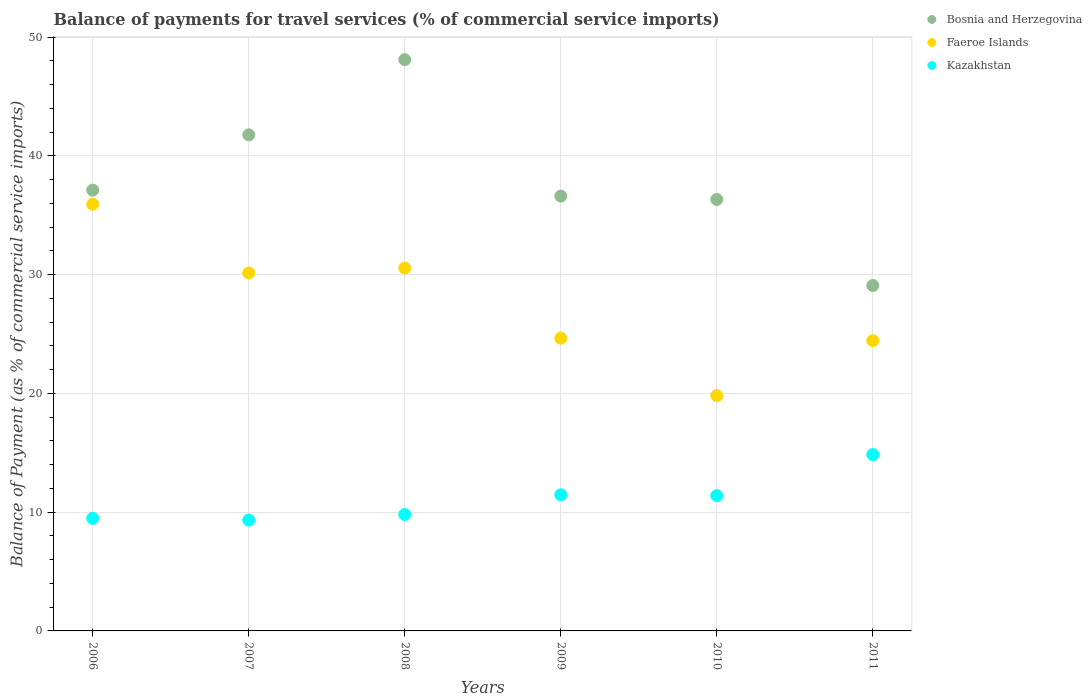Is the number of dotlines equal to the number of legend labels?
Keep it short and to the point. Yes. What is the balance of payments for travel services in Bosnia and Herzegovina in 2008?
Keep it short and to the point. 48.11. Across all years, what is the maximum balance of payments for travel services in Kazakhstan?
Your response must be concise. 14.85. Across all years, what is the minimum balance of payments for travel services in Kazakhstan?
Make the answer very short. 9.33. In which year was the balance of payments for travel services in Faeroe Islands maximum?
Offer a terse response. 2006. What is the total balance of payments for travel services in Faeroe Islands in the graph?
Provide a short and direct response. 165.53. What is the difference between the balance of payments for travel services in Faeroe Islands in 2007 and that in 2010?
Provide a short and direct response. 10.33. What is the difference between the balance of payments for travel services in Bosnia and Herzegovina in 2006 and the balance of payments for travel services in Kazakhstan in 2007?
Offer a very short reply. 27.79. What is the average balance of payments for travel services in Bosnia and Herzegovina per year?
Keep it short and to the point. 38.17. In the year 2006, what is the difference between the balance of payments for travel services in Bosnia and Herzegovina and balance of payments for travel services in Faeroe Islands?
Ensure brevity in your answer.  1.19. What is the ratio of the balance of payments for travel services in Faeroe Islands in 2008 to that in 2011?
Offer a very short reply. 1.25. What is the difference between the highest and the second highest balance of payments for travel services in Bosnia and Herzegovina?
Provide a short and direct response. 6.34. What is the difference between the highest and the lowest balance of payments for travel services in Kazakhstan?
Offer a terse response. 5.52. In how many years, is the balance of payments for travel services in Faeroe Islands greater than the average balance of payments for travel services in Faeroe Islands taken over all years?
Ensure brevity in your answer.  3. Is it the case that in every year, the sum of the balance of payments for travel services in Bosnia and Herzegovina and balance of payments for travel services in Faeroe Islands  is greater than the balance of payments for travel services in Kazakhstan?
Ensure brevity in your answer.  Yes. Is the balance of payments for travel services in Kazakhstan strictly greater than the balance of payments for travel services in Faeroe Islands over the years?
Make the answer very short. No. Are the values on the major ticks of Y-axis written in scientific E-notation?
Offer a terse response. No. Does the graph contain grids?
Offer a terse response. Yes. What is the title of the graph?
Your answer should be very brief. Balance of payments for travel services (% of commercial service imports). What is the label or title of the X-axis?
Ensure brevity in your answer.  Years. What is the label or title of the Y-axis?
Provide a succinct answer. Balance of Payment (as % of commercial service imports). What is the Balance of Payment (as % of commercial service imports) of Bosnia and Herzegovina in 2006?
Your response must be concise. 37.12. What is the Balance of Payment (as % of commercial service imports) in Faeroe Islands in 2006?
Provide a short and direct response. 35.93. What is the Balance of Payment (as % of commercial service imports) in Kazakhstan in 2006?
Your answer should be compact. 9.48. What is the Balance of Payment (as % of commercial service imports) of Bosnia and Herzegovina in 2007?
Provide a short and direct response. 41.77. What is the Balance of Payment (as % of commercial service imports) of Faeroe Islands in 2007?
Make the answer very short. 30.14. What is the Balance of Payment (as % of commercial service imports) in Kazakhstan in 2007?
Give a very brief answer. 9.33. What is the Balance of Payment (as % of commercial service imports) of Bosnia and Herzegovina in 2008?
Make the answer very short. 48.11. What is the Balance of Payment (as % of commercial service imports) of Faeroe Islands in 2008?
Provide a succinct answer. 30.55. What is the Balance of Payment (as % of commercial service imports) of Kazakhstan in 2008?
Offer a very short reply. 9.8. What is the Balance of Payment (as % of commercial service imports) of Bosnia and Herzegovina in 2009?
Give a very brief answer. 36.61. What is the Balance of Payment (as % of commercial service imports) of Faeroe Islands in 2009?
Your answer should be compact. 24.65. What is the Balance of Payment (as % of commercial service imports) in Kazakhstan in 2009?
Provide a short and direct response. 11.46. What is the Balance of Payment (as % of commercial service imports) in Bosnia and Herzegovina in 2010?
Offer a terse response. 36.33. What is the Balance of Payment (as % of commercial service imports) of Faeroe Islands in 2010?
Offer a very short reply. 19.81. What is the Balance of Payment (as % of commercial service imports) in Kazakhstan in 2010?
Keep it short and to the point. 11.39. What is the Balance of Payment (as % of commercial service imports) of Bosnia and Herzegovina in 2011?
Keep it short and to the point. 29.08. What is the Balance of Payment (as % of commercial service imports) in Faeroe Islands in 2011?
Your answer should be very brief. 24.44. What is the Balance of Payment (as % of commercial service imports) in Kazakhstan in 2011?
Give a very brief answer. 14.85. Across all years, what is the maximum Balance of Payment (as % of commercial service imports) in Bosnia and Herzegovina?
Give a very brief answer. 48.11. Across all years, what is the maximum Balance of Payment (as % of commercial service imports) in Faeroe Islands?
Your response must be concise. 35.93. Across all years, what is the maximum Balance of Payment (as % of commercial service imports) of Kazakhstan?
Keep it short and to the point. 14.85. Across all years, what is the minimum Balance of Payment (as % of commercial service imports) of Bosnia and Herzegovina?
Offer a terse response. 29.08. Across all years, what is the minimum Balance of Payment (as % of commercial service imports) of Faeroe Islands?
Keep it short and to the point. 19.81. Across all years, what is the minimum Balance of Payment (as % of commercial service imports) of Kazakhstan?
Give a very brief answer. 9.33. What is the total Balance of Payment (as % of commercial service imports) of Bosnia and Herzegovina in the graph?
Offer a very short reply. 229.02. What is the total Balance of Payment (as % of commercial service imports) in Faeroe Islands in the graph?
Make the answer very short. 165.53. What is the total Balance of Payment (as % of commercial service imports) of Kazakhstan in the graph?
Offer a very short reply. 66.31. What is the difference between the Balance of Payment (as % of commercial service imports) in Bosnia and Herzegovina in 2006 and that in 2007?
Give a very brief answer. -4.66. What is the difference between the Balance of Payment (as % of commercial service imports) in Faeroe Islands in 2006 and that in 2007?
Give a very brief answer. 5.79. What is the difference between the Balance of Payment (as % of commercial service imports) in Kazakhstan in 2006 and that in 2007?
Offer a very short reply. 0.15. What is the difference between the Balance of Payment (as % of commercial service imports) in Bosnia and Herzegovina in 2006 and that in 2008?
Your answer should be compact. -10.99. What is the difference between the Balance of Payment (as % of commercial service imports) in Faeroe Islands in 2006 and that in 2008?
Keep it short and to the point. 5.37. What is the difference between the Balance of Payment (as % of commercial service imports) of Kazakhstan in 2006 and that in 2008?
Offer a terse response. -0.32. What is the difference between the Balance of Payment (as % of commercial service imports) of Bosnia and Herzegovina in 2006 and that in 2009?
Keep it short and to the point. 0.5. What is the difference between the Balance of Payment (as % of commercial service imports) in Faeroe Islands in 2006 and that in 2009?
Provide a succinct answer. 11.27. What is the difference between the Balance of Payment (as % of commercial service imports) of Kazakhstan in 2006 and that in 2009?
Provide a succinct answer. -1.98. What is the difference between the Balance of Payment (as % of commercial service imports) in Bosnia and Herzegovina in 2006 and that in 2010?
Your answer should be very brief. 0.79. What is the difference between the Balance of Payment (as % of commercial service imports) of Faeroe Islands in 2006 and that in 2010?
Give a very brief answer. 16.11. What is the difference between the Balance of Payment (as % of commercial service imports) in Kazakhstan in 2006 and that in 2010?
Your answer should be very brief. -1.91. What is the difference between the Balance of Payment (as % of commercial service imports) in Bosnia and Herzegovina in 2006 and that in 2011?
Offer a terse response. 8.03. What is the difference between the Balance of Payment (as % of commercial service imports) of Faeroe Islands in 2006 and that in 2011?
Provide a short and direct response. 11.49. What is the difference between the Balance of Payment (as % of commercial service imports) in Kazakhstan in 2006 and that in 2011?
Offer a very short reply. -5.37. What is the difference between the Balance of Payment (as % of commercial service imports) in Bosnia and Herzegovina in 2007 and that in 2008?
Keep it short and to the point. -6.34. What is the difference between the Balance of Payment (as % of commercial service imports) of Faeroe Islands in 2007 and that in 2008?
Make the answer very short. -0.41. What is the difference between the Balance of Payment (as % of commercial service imports) of Kazakhstan in 2007 and that in 2008?
Provide a short and direct response. -0.47. What is the difference between the Balance of Payment (as % of commercial service imports) in Bosnia and Herzegovina in 2007 and that in 2009?
Ensure brevity in your answer.  5.16. What is the difference between the Balance of Payment (as % of commercial service imports) of Faeroe Islands in 2007 and that in 2009?
Provide a succinct answer. 5.49. What is the difference between the Balance of Payment (as % of commercial service imports) of Kazakhstan in 2007 and that in 2009?
Your answer should be very brief. -2.13. What is the difference between the Balance of Payment (as % of commercial service imports) in Bosnia and Herzegovina in 2007 and that in 2010?
Provide a succinct answer. 5.44. What is the difference between the Balance of Payment (as % of commercial service imports) of Faeroe Islands in 2007 and that in 2010?
Your response must be concise. 10.33. What is the difference between the Balance of Payment (as % of commercial service imports) of Kazakhstan in 2007 and that in 2010?
Give a very brief answer. -2.06. What is the difference between the Balance of Payment (as % of commercial service imports) in Bosnia and Herzegovina in 2007 and that in 2011?
Your response must be concise. 12.69. What is the difference between the Balance of Payment (as % of commercial service imports) of Faeroe Islands in 2007 and that in 2011?
Your answer should be very brief. 5.7. What is the difference between the Balance of Payment (as % of commercial service imports) in Kazakhstan in 2007 and that in 2011?
Provide a succinct answer. -5.52. What is the difference between the Balance of Payment (as % of commercial service imports) in Bosnia and Herzegovina in 2008 and that in 2009?
Your response must be concise. 11.49. What is the difference between the Balance of Payment (as % of commercial service imports) of Faeroe Islands in 2008 and that in 2009?
Your answer should be very brief. 5.9. What is the difference between the Balance of Payment (as % of commercial service imports) in Kazakhstan in 2008 and that in 2009?
Your response must be concise. -1.66. What is the difference between the Balance of Payment (as % of commercial service imports) of Bosnia and Herzegovina in 2008 and that in 2010?
Make the answer very short. 11.78. What is the difference between the Balance of Payment (as % of commercial service imports) in Faeroe Islands in 2008 and that in 2010?
Make the answer very short. 10.74. What is the difference between the Balance of Payment (as % of commercial service imports) in Kazakhstan in 2008 and that in 2010?
Ensure brevity in your answer.  -1.59. What is the difference between the Balance of Payment (as % of commercial service imports) in Bosnia and Herzegovina in 2008 and that in 2011?
Your answer should be very brief. 19.02. What is the difference between the Balance of Payment (as % of commercial service imports) in Faeroe Islands in 2008 and that in 2011?
Offer a terse response. 6.11. What is the difference between the Balance of Payment (as % of commercial service imports) of Kazakhstan in 2008 and that in 2011?
Give a very brief answer. -5.05. What is the difference between the Balance of Payment (as % of commercial service imports) in Bosnia and Herzegovina in 2009 and that in 2010?
Keep it short and to the point. 0.28. What is the difference between the Balance of Payment (as % of commercial service imports) in Faeroe Islands in 2009 and that in 2010?
Provide a short and direct response. 4.84. What is the difference between the Balance of Payment (as % of commercial service imports) of Kazakhstan in 2009 and that in 2010?
Offer a terse response. 0.07. What is the difference between the Balance of Payment (as % of commercial service imports) of Bosnia and Herzegovina in 2009 and that in 2011?
Offer a terse response. 7.53. What is the difference between the Balance of Payment (as % of commercial service imports) of Faeroe Islands in 2009 and that in 2011?
Your answer should be very brief. 0.22. What is the difference between the Balance of Payment (as % of commercial service imports) of Kazakhstan in 2009 and that in 2011?
Your response must be concise. -3.39. What is the difference between the Balance of Payment (as % of commercial service imports) in Bosnia and Herzegovina in 2010 and that in 2011?
Provide a succinct answer. 7.25. What is the difference between the Balance of Payment (as % of commercial service imports) of Faeroe Islands in 2010 and that in 2011?
Offer a very short reply. -4.63. What is the difference between the Balance of Payment (as % of commercial service imports) of Kazakhstan in 2010 and that in 2011?
Provide a succinct answer. -3.46. What is the difference between the Balance of Payment (as % of commercial service imports) in Bosnia and Herzegovina in 2006 and the Balance of Payment (as % of commercial service imports) in Faeroe Islands in 2007?
Your response must be concise. 6.97. What is the difference between the Balance of Payment (as % of commercial service imports) of Bosnia and Herzegovina in 2006 and the Balance of Payment (as % of commercial service imports) of Kazakhstan in 2007?
Your answer should be very brief. 27.79. What is the difference between the Balance of Payment (as % of commercial service imports) of Faeroe Islands in 2006 and the Balance of Payment (as % of commercial service imports) of Kazakhstan in 2007?
Offer a very short reply. 26.6. What is the difference between the Balance of Payment (as % of commercial service imports) in Bosnia and Herzegovina in 2006 and the Balance of Payment (as % of commercial service imports) in Faeroe Islands in 2008?
Give a very brief answer. 6.56. What is the difference between the Balance of Payment (as % of commercial service imports) in Bosnia and Herzegovina in 2006 and the Balance of Payment (as % of commercial service imports) in Kazakhstan in 2008?
Your response must be concise. 27.32. What is the difference between the Balance of Payment (as % of commercial service imports) of Faeroe Islands in 2006 and the Balance of Payment (as % of commercial service imports) of Kazakhstan in 2008?
Your answer should be very brief. 26.13. What is the difference between the Balance of Payment (as % of commercial service imports) in Bosnia and Herzegovina in 2006 and the Balance of Payment (as % of commercial service imports) in Faeroe Islands in 2009?
Your answer should be very brief. 12.46. What is the difference between the Balance of Payment (as % of commercial service imports) of Bosnia and Herzegovina in 2006 and the Balance of Payment (as % of commercial service imports) of Kazakhstan in 2009?
Make the answer very short. 25.65. What is the difference between the Balance of Payment (as % of commercial service imports) of Faeroe Islands in 2006 and the Balance of Payment (as % of commercial service imports) of Kazakhstan in 2009?
Keep it short and to the point. 24.47. What is the difference between the Balance of Payment (as % of commercial service imports) of Bosnia and Herzegovina in 2006 and the Balance of Payment (as % of commercial service imports) of Faeroe Islands in 2010?
Offer a terse response. 17.3. What is the difference between the Balance of Payment (as % of commercial service imports) in Bosnia and Herzegovina in 2006 and the Balance of Payment (as % of commercial service imports) in Kazakhstan in 2010?
Your answer should be very brief. 25.72. What is the difference between the Balance of Payment (as % of commercial service imports) of Faeroe Islands in 2006 and the Balance of Payment (as % of commercial service imports) of Kazakhstan in 2010?
Ensure brevity in your answer.  24.54. What is the difference between the Balance of Payment (as % of commercial service imports) in Bosnia and Herzegovina in 2006 and the Balance of Payment (as % of commercial service imports) in Faeroe Islands in 2011?
Provide a succinct answer. 12.68. What is the difference between the Balance of Payment (as % of commercial service imports) in Bosnia and Herzegovina in 2006 and the Balance of Payment (as % of commercial service imports) in Kazakhstan in 2011?
Provide a short and direct response. 22.27. What is the difference between the Balance of Payment (as % of commercial service imports) in Faeroe Islands in 2006 and the Balance of Payment (as % of commercial service imports) in Kazakhstan in 2011?
Provide a succinct answer. 21.08. What is the difference between the Balance of Payment (as % of commercial service imports) of Bosnia and Herzegovina in 2007 and the Balance of Payment (as % of commercial service imports) of Faeroe Islands in 2008?
Your answer should be compact. 11.22. What is the difference between the Balance of Payment (as % of commercial service imports) of Bosnia and Herzegovina in 2007 and the Balance of Payment (as % of commercial service imports) of Kazakhstan in 2008?
Your answer should be compact. 31.97. What is the difference between the Balance of Payment (as % of commercial service imports) in Faeroe Islands in 2007 and the Balance of Payment (as % of commercial service imports) in Kazakhstan in 2008?
Make the answer very short. 20.34. What is the difference between the Balance of Payment (as % of commercial service imports) of Bosnia and Herzegovina in 2007 and the Balance of Payment (as % of commercial service imports) of Faeroe Islands in 2009?
Your answer should be very brief. 17.12. What is the difference between the Balance of Payment (as % of commercial service imports) in Bosnia and Herzegovina in 2007 and the Balance of Payment (as % of commercial service imports) in Kazakhstan in 2009?
Keep it short and to the point. 30.31. What is the difference between the Balance of Payment (as % of commercial service imports) of Faeroe Islands in 2007 and the Balance of Payment (as % of commercial service imports) of Kazakhstan in 2009?
Provide a succinct answer. 18.68. What is the difference between the Balance of Payment (as % of commercial service imports) in Bosnia and Herzegovina in 2007 and the Balance of Payment (as % of commercial service imports) in Faeroe Islands in 2010?
Your answer should be very brief. 21.96. What is the difference between the Balance of Payment (as % of commercial service imports) in Bosnia and Herzegovina in 2007 and the Balance of Payment (as % of commercial service imports) in Kazakhstan in 2010?
Offer a terse response. 30.38. What is the difference between the Balance of Payment (as % of commercial service imports) of Faeroe Islands in 2007 and the Balance of Payment (as % of commercial service imports) of Kazakhstan in 2010?
Provide a succinct answer. 18.75. What is the difference between the Balance of Payment (as % of commercial service imports) in Bosnia and Herzegovina in 2007 and the Balance of Payment (as % of commercial service imports) in Faeroe Islands in 2011?
Offer a very short reply. 17.33. What is the difference between the Balance of Payment (as % of commercial service imports) in Bosnia and Herzegovina in 2007 and the Balance of Payment (as % of commercial service imports) in Kazakhstan in 2011?
Your answer should be very brief. 26.92. What is the difference between the Balance of Payment (as % of commercial service imports) in Faeroe Islands in 2007 and the Balance of Payment (as % of commercial service imports) in Kazakhstan in 2011?
Provide a short and direct response. 15.29. What is the difference between the Balance of Payment (as % of commercial service imports) in Bosnia and Herzegovina in 2008 and the Balance of Payment (as % of commercial service imports) in Faeroe Islands in 2009?
Give a very brief answer. 23.45. What is the difference between the Balance of Payment (as % of commercial service imports) of Bosnia and Herzegovina in 2008 and the Balance of Payment (as % of commercial service imports) of Kazakhstan in 2009?
Provide a succinct answer. 36.64. What is the difference between the Balance of Payment (as % of commercial service imports) in Faeroe Islands in 2008 and the Balance of Payment (as % of commercial service imports) in Kazakhstan in 2009?
Offer a very short reply. 19.09. What is the difference between the Balance of Payment (as % of commercial service imports) of Bosnia and Herzegovina in 2008 and the Balance of Payment (as % of commercial service imports) of Faeroe Islands in 2010?
Offer a terse response. 28.29. What is the difference between the Balance of Payment (as % of commercial service imports) of Bosnia and Herzegovina in 2008 and the Balance of Payment (as % of commercial service imports) of Kazakhstan in 2010?
Give a very brief answer. 36.72. What is the difference between the Balance of Payment (as % of commercial service imports) in Faeroe Islands in 2008 and the Balance of Payment (as % of commercial service imports) in Kazakhstan in 2010?
Give a very brief answer. 19.16. What is the difference between the Balance of Payment (as % of commercial service imports) in Bosnia and Herzegovina in 2008 and the Balance of Payment (as % of commercial service imports) in Faeroe Islands in 2011?
Offer a very short reply. 23.67. What is the difference between the Balance of Payment (as % of commercial service imports) of Bosnia and Herzegovina in 2008 and the Balance of Payment (as % of commercial service imports) of Kazakhstan in 2011?
Give a very brief answer. 33.26. What is the difference between the Balance of Payment (as % of commercial service imports) of Faeroe Islands in 2008 and the Balance of Payment (as % of commercial service imports) of Kazakhstan in 2011?
Your answer should be very brief. 15.71. What is the difference between the Balance of Payment (as % of commercial service imports) of Bosnia and Herzegovina in 2009 and the Balance of Payment (as % of commercial service imports) of Faeroe Islands in 2010?
Offer a terse response. 16.8. What is the difference between the Balance of Payment (as % of commercial service imports) of Bosnia and Herzegovina in 2009 and the Balance of Payment (as % of commercial service imports) of Kazakhstan in 2010?
Make the answer very short. 25.22. What is the difference between the Balance of Payment (as % of commercial service imports) in Faeroe Islands in 2009 and the Balance of Payment (as % of commercial service imports) in Kazakhstan in 2010?
Your answer should be compact. 13.26. What is the difference between the Balance of Payment (as % of commercial service imports) in Bosnia and Herzegovina in 2009 and the Balance of Payment (as % of commercial service imports) in Faeroe Islands in 2011?
Your answer should be compact. 12.17. What is the difference between the Balance of Payment (as % of commercial service imports) in Bosnia and Herzegovina in 2009 and the Balance of Payment (as % of commercial service imports) in Kazakhstan in 2011?
Offer a very short reply. 21.77. What is the difference between the Balance of Payment (as % of commercial service imports) in Faeroe Islands in 2009 and the Balance of Payment (as % of commercial service imports) in Kazakhstan in 2011?
Make the answer very short. 9.81. What is the difference between the Balance of Payment (as % of commercial service imports) of Bosnia and Herzegovina in 2010 and the Balance of Payment (as % of commercial service imports) of Faeroe Islands in 2011?
Make the answer very short. 11.89. What is the difference between the Balance of Payment (as % of commercial service imports) in Bosnia and Herzegovina in 2010 and the Balance of Payment (as % of commercial service imports) in Kazakhstan in 2011?
Your response must be concise. 21.48. What is the difference between the Balance of Payment (as % of commercial service imports) of Faeroe Islands in 2010 and the Balance of Payment (as % of commercial service imports) of Kazakhstan in 2011?
Provide a succinct answer. 4.97. What is the average Balance of Payment (as % of commercial service imports) in Bosnia and Herzegovina per year?
Keep it short and to the point. 38.17. What is the average Balance of Payment (as % of commercial service imports) in Faeroe Islands per year?
Keep it short and to the point. 27.59. What is the average Balance of Payment (as % of commercial service imports) in Kazakhstan per year?
Your response must be concise. 11.05. In the year 2006, what is the difference between the Balance of Payment (as % of commercial service imports) of Bosnia and Herzegovina and Balance of Payment (as % of commercial service imports) of Faeroe Islands?
Keep it short and to the point. 1.19. In the year 2006, what is the difference between the Balance of Payment (as % of commercial service imports) of Bosnia and Herzegovina and Balance of Payment (as % of commercial service imports) of Kazakhstan?
Provide a succinct answer. 27.64. In the year 2006, what is the difference between the Balance of Payment (as % of commercial service imports) of Faeroe Islands and Balance of Payment (as % of commercial service imports) of Kazakhstan?
Keep it short and to the point. 26.45. In the year 2007, what is the difference between the Balance of Payment (as % of commercial service imports) in Bosnia and Herzegovina and Balance of Payment (as % of commercial service imports) in Faeroe Islands?
Provide a succinct answer. 11.63. In the year 2007, what is the difference between the Balance of Payment (as % of commercial service imports) of Bosnia and Herzegovina and Balance of Payment (as % of commercial service imports) of Kazakhstan?
Offer a very short reply. 32.44. In the year 2007, what is the difference between the Balance of Payment (as % of commercial service imports) of Faeroe Islands and Balance of Payment (as % of commercial service imports) of Kazakhstan?
Make the answer very short. 20.81. In the year 2008, what is the difference between the Balance of Payment (as % of commercial service imports) in Bosnia and Herzegovina and Balance of Payment (as % of commercial service imports) in Faeroe Islands?
Keep it short and to the point. 17.55. In the year 2008, what is the difference between the Balance of Payment (as % of commercial service imports) in Bosnia and Herzegovina and Balance of Payment (as % of commercial service imports) in Kazakhstan?
Your response must be concise. 38.31. In the year 2008, what is the difference between the Balance of Payment (as % of commercial service imports) in Faeroe Islands and Balance of Payment (as % of commercial service imports) in Kazakhstan?
Your answer should be compact. 20.76. In the year 2009, what is the difference between the Balance of Payment (as % of commercial service imports) in Bosnia and Herzegovina and Balance of Payment (as % of commercial service imports) in Faeroe Islands?
Ensure brevity in your answer.  11.96. In the year 2009, what is the difference between the Balance of Payment (as % of commercial service imports) in Bosnia and Herzegovina and Balance of Payment (as % of commercial service imports) in Kazakhstan?
Your answer should be compact. 25.15. In the year 2009, what is the difference between the Balance of Payment (as % of commercial service imports) of Faeroe Islands and Balance of Payment (as % of commercial service imports) of Kazakhstan?
Give a very brief answer. 13.19. In the year 2010, what is the difference between the Balance of Payment (as % of commercial service imports) in Bosnia and Herzegovina and Balance of Payment (as % of commercial service imports) in Faeroe Islands?
Your answer should be very brief. 16.52. In the year 2010, what is the difference between the Balance of Payment (as % of commercial service imports) in Bosnia and Herzegovina and Balance of Payment (as % of commercial service imports) in Kazakhstan?
Offer a very short reply. 24.94. In the year 2010, what is the difference between the Balance of Payment (as % of commercial service imports) in Faeroe Islands and Balance of Payment (as % of commercial service imports) in Kazakhstan?
Offer a terse response. 8.42. In the year 2011, what is the difference between the Balance of Payment (as % of commercial service imports) in Bosnia and Herzegovina and Balance of Payment (as % of commercial service imports) in Faeroe Islands?
Give a very brief answer. 4.65. In the year 2011, what is the difference between the Balance of Payment (as % of commercial service imports) in Bosnia and Herzegovina and Balance of Payment (as % of commercial service imports) in Kazakhstan?
Keep it short and to the point. 14.24. In the year 2011, what is the difference between the Balance of Payment (as % of commercial service imports) in Faeroe Islands and Balance of Payment (as % of commercial service imports) in Kazakhstan?
Ensure brevity in your answer.  9.59. What is the ratio of the Balance of Payment (as % of commercial service imports) in Bosnia and Herzegovina in 2006 to that in 2007?
Make the answer very short. 0.89. What is the ratio of the Balance of Payment (as % of commercial service imports) in Faeroe Islands in 2006 to that in 2007?
Offer a very short reply. 1.19. What is the ratio of the Balance of Payment (as % of commercial service imports) of Kazakhstan in 2006 to that in 2007?
Offer a terse response. 1.02. What is the ratio of the Balance of Payment (as % of commercial service imports) of Bosnia and Herzegovina in 2006 to that in 2008?
Make the answer very short. 0.77. What is the ratio of the Balance of Payment (as % of commercial service imports) of Faeroe Islands in 2006 to that in 2008?
Your answer should be very brief. 1.18. What is the ratio of the Balance of Payment (as % of commercial service imports) of Kazakhstan in 2006 to that in 2008?
Give a very brief answer. 0.97. What is the ratio of the Balance of Payment (as % of commercial service imports) in Bosnia and Herzegovina in 2006 to that in 2009?
Your response must be concise. 1.01. What is the ratio of the Balance of Payment (as % of commercial service imports) in Faeroe Islands in 2006 to that in 2009?
Ensure brevity in your answer.  1.46. What is the ratio of the Balance of Payment (as % of commercial service imports) of Kazakhstan in 2006 to that in 2009?
Provide a succinct answer. 0.83. What is the ratio of the Balance of Payment (as % of commercial service imports) in Bosnia and Herzegovina in 2006 to that in 2010?
Provide a short and direct response. 1.02. What is the ratio of the Balance of Payment (as % of commercial service imports) in Faeroe Islands in 2006 to that in 2010?
Provide a short and direct response. 1.81. What is the ratio of the Balance of Payment (as % of commercial service imports) in Kazakhstan in 2006 to that in 2010?
Keep it short and to the point. 0.83. What is the ratio of the Balance of Payment (as % of commercial service imports) of Bosnia and Herzegovina in 2006 to that in 2011?
Your response must be concise. 1.28. What is the ratio of the Balance of Payment (as % of commercial service imports) of Faeroe Islands in 2006 to that in 2011?
Your response must be concise. 1.47. What is the ratio of the Balance of Payment (as % of commercial service imports) in Kazakhstan in 2006 to that in 2011?
Keep it short and to the point. 0.64. What is the ratio of the Balance of Payment (as % of commercial service imports) of Bosnia and Herzegovina in 2007 to that in 2008?
Your answer should be very brief. 0.87. What is the ratio of the Balance of Payment (as % of commercial service imports) in Faeroe Islands in 2007 to that in 2008?
Keep it short and to the point. 0.99. What is the ratio of the Balance of Payment (as % of commercial service imports) in Kazakhstan in 2007 to that in 2008?
Give a very brief answer. 0.95. What is the ratio of the Balance of Payment (as % of commercial service imports) of Bosnia and Herzegovina in 2007 to that in 2009?
Provide a succinct answer. 1.14. What is the ratio of the Balance of Payment (as % of commercial service imports) of Faeroe Islands in 2007 to that in 2009?
Give a very brief answer. 1.22. What is the ratio of the Balance of Payment (as % of commercial service imports) of Kazakhstan in 2007 to that in 2009?
Your answer should be compact. 0.81. What is the ratio of the Balance of Payment (as % of commercial service imports) of Bosnia and Herzegovina in 2007 to that in 2010?
Provide a short and direct response. 1.15. What is the ratio of the Balance of Payment (as % of commercial service imports) in Faeroe Islands in 2007 to that in 2010?
Make the answer very short. 1.52. What is the ratio of the Balance of Payment (as % of commercial service imports) in Kazakhstan in 2007 to that in 2010?
Your response must be concise. 0.82. What is the ratio of the Balance of Payment (as % of commercial service imports) of Bosnia and Herzegovina in 2007 to that in 2011?
Provide a short and direct response. 1.44. What is the ratio of the Balance of Payment (as % of commercial service imports) of Faeroe Islands in 2007 to that in 2011?
Keep it short and to the point. 1.23. What is the ratio of the Balance of Payment (as % of commercial service imports) in Kazakhstan in 2007 to that in 2011?
Your answer should be very brief. 0.63. What is the ratio of the Balance of Payment (as % of commercial service imports) of Bosnia and Herzegovina in 2008 to that in 2009?
Make the answer very short. 1.31. What is the ratio of the Balance of Payment (as % of commercial service imports) in Faeroe Islands in 2008 to that in 2009?
Offer a terse response. 1.24. What is the ratio of the Balance of Payment (as % of commercial service imports) in Kazakhstan in 2008 to that in 2009?
Give a very brief answer. 0.85. What is the ratio of the Balance of Payment (as % of commercial service imports) of Bosnia and Herzegovina in 2008 to that in 2010?
Offer a very short reply. 1.32. What is the ratio of the Balance of Payment (as % of commercial service imports) in Faeroe Islands in 2008 to that in 2010?
Your response must be concise. 1.54. What is the ratio of the Balance of Payment (as % of commercial service imports) in Kazakhstan in 2008 to that in 2010?
Offer a very short reply. 0.86. What is the ratio of the Balance of Payment (as % of commercial service imports) in Bosnia and Herzegovina in 2008 to that in 2011?
Make the answer very short. 1.65. What is the ratio of the Balance of Payment (as % of commercial service imports) of Faeroe Islands in 2008 to that in 2011?
Provide a succinct answer. 1.25. What is the ratio of the Balance of Payment (as % of commercial service imports) in Kazakhstan in 2008 to that in 2011?
Give a very brief answer. 0.66. What is the ratio of the Balance of Payment (as % of commercial service imports) in Bosnia and Herzegovina in 2009 to that in 2010?
Provide a short and direct response. 1.01. What is the ratio of the Balance of Payment (as % of commercial service imports) of Faeroe Islands in 2009 to that in 2010?
Your answer should be very brief. 1.24. What is the ratio of the Balance of Payment (as % of commercial service imports) in Kazakhstan in 2009 to that in 2010?
Your answer should be compact. 1.01. What is the ratio of the Balance of Payment (as % of commercial service imports) of Bosnia and Herzegovina in 2009 to that in 2011?
Offer a terse response. 1.26. What is the ratio of the Balance of Payment (as % of commercial service imports) in Faeroe Islands in 2009 to that in 2011?
Provide a short and direct response. 1.01. What is the ratio of the Balance of Payment (as % of commercial service imports) of Kazakhstan in 2009 to that in 2011?
Offer a terse response. 0.77. What is the ratio of the Balance of Payment (as % of commercial service imports) in Bosnia and Herzegovina in 2010 to that in 2011?
Ensure brevity in your answer.  1.25. What is the ratio of the Balance of Payment (as % of commercial service imports) in Faeroe Islands in 2010 to that in 2011?
Your answer should be compact. 0.81. What is the ratio of the Balance of Payment (as % of commercial service imports) in Kazakhstan in 2010 to that in 2011?
Offer a very short reply. 0.77. What is the difference between the highest and the second highest Balance of Payment (as % of commercial service imports) of Bosnia and Herzegovina?
Offer a very short reply. 6.34. What is the difference between the highest and the second highest Balance of Payment (as % of commercial service imports) of Faeroe Islands?
Your answer should be compact. 5.37. What is the difference between the highest and the second highest Balance of Payment (as % of commercial service imports) in Kazakhstan?
Your answer should be very brief. 3.39. What is the difference between the highest and the lowest Balance of Payment (as % of commercial service imports) in Bosnia and Herzegovina?
Your answer should be compact. 19.02. What is the difference between the highest and the lowest Balance of Payment (as % of commercial service imports) in Faeroe Islands?
Offer a terse response. 16.11. What is the difference between the highest and the lowest Balance of Payment (as % of commercial service imports) in Kazakhstan?
Give a very brief answer. 5.52. 